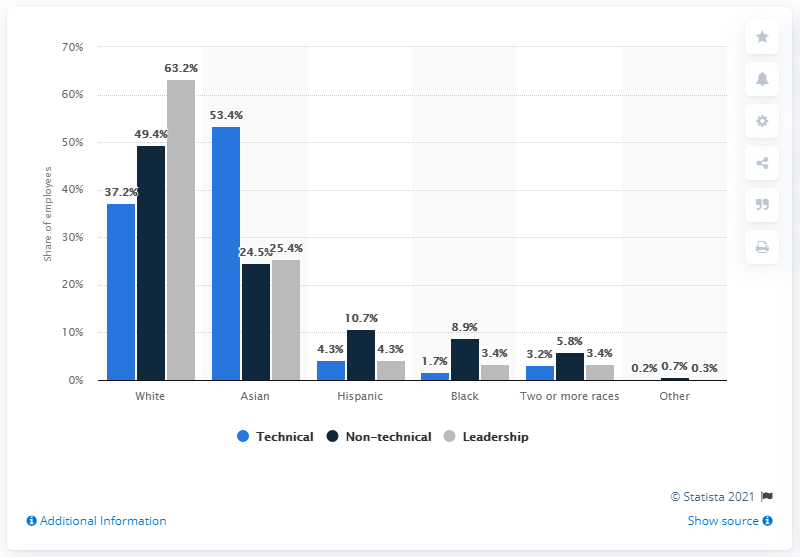Indicate a few pertinent items in this graphic. In June 2020, approximately 4.3% of Facebook's senior level employees were Hispanic. According to the data, 4.3% of Facebook's senior level employees belong to the Hispanic ethnicity. 